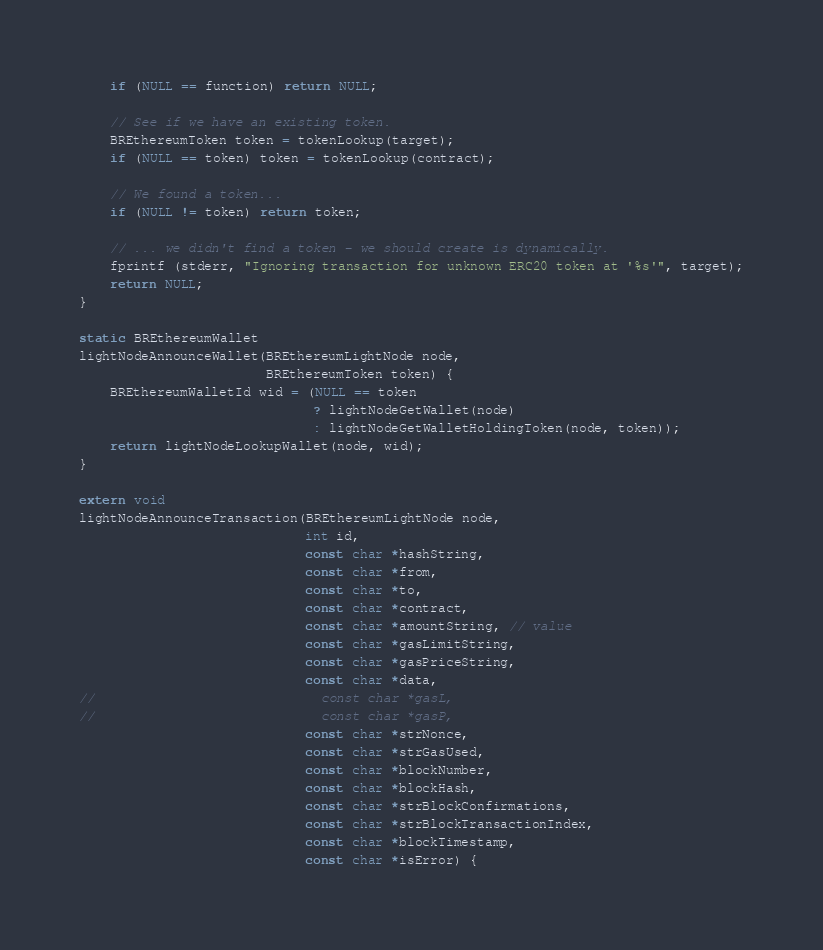<code> <loc_0><loc_0><loc_500><loc_500><_C_>    if (NULL == function) return NULL;

    // See if we have an existing token.
    BREthereumToken token = tokenLookup(target);
    if (NULL == token) token = tokenLookup(contract);

    // We found a token...
    if (NULL != token) return token;

    // ... we didn't find a token - we should create is dynamically.
    fprintf (stderr, "Ignoring transaction for unknown ERC20 token at '%s'", target);
    return NULL;
}

static BREthereumWallet
lightNodeAnnounceWallet(BREthereumLightNode node,
                        BREthereumToken token) {
    BREthereumWalletId wid = (NULL == token
                              ? lightNodeGetWallet(node)
                              : lightNodeGetWalletHoldingToken(node, token));
    return lightNodeLookupWallet(node, wid);
}

extern void
lightNodeAnnounceTransaction(BREthereumLightNode node,
                             int id,
                             const char *hashString,
                             const char *from,
                             const char *to,
                             const char *contract,
                             const char *amountString, // value
                             const char *gasLimitString,
                             const char *gasPriceString,
                             const char *data,
//                             const char *gasL,
//                             const char *gasP,
                             const char *strNonce,
                             const char *strGasUsed,
                             const char *blockNumber,
                             const char *blockHash,
                             const char *strBlockConfirmations,
                             const char *strBlockTransactionIndex,
                             const char *blockTimestamp,
                             const char *isError) {</code> 